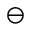Convert formula to latex. <formula><loc_0><loc_0><loc_500><loc_500>\ominus</formula> 